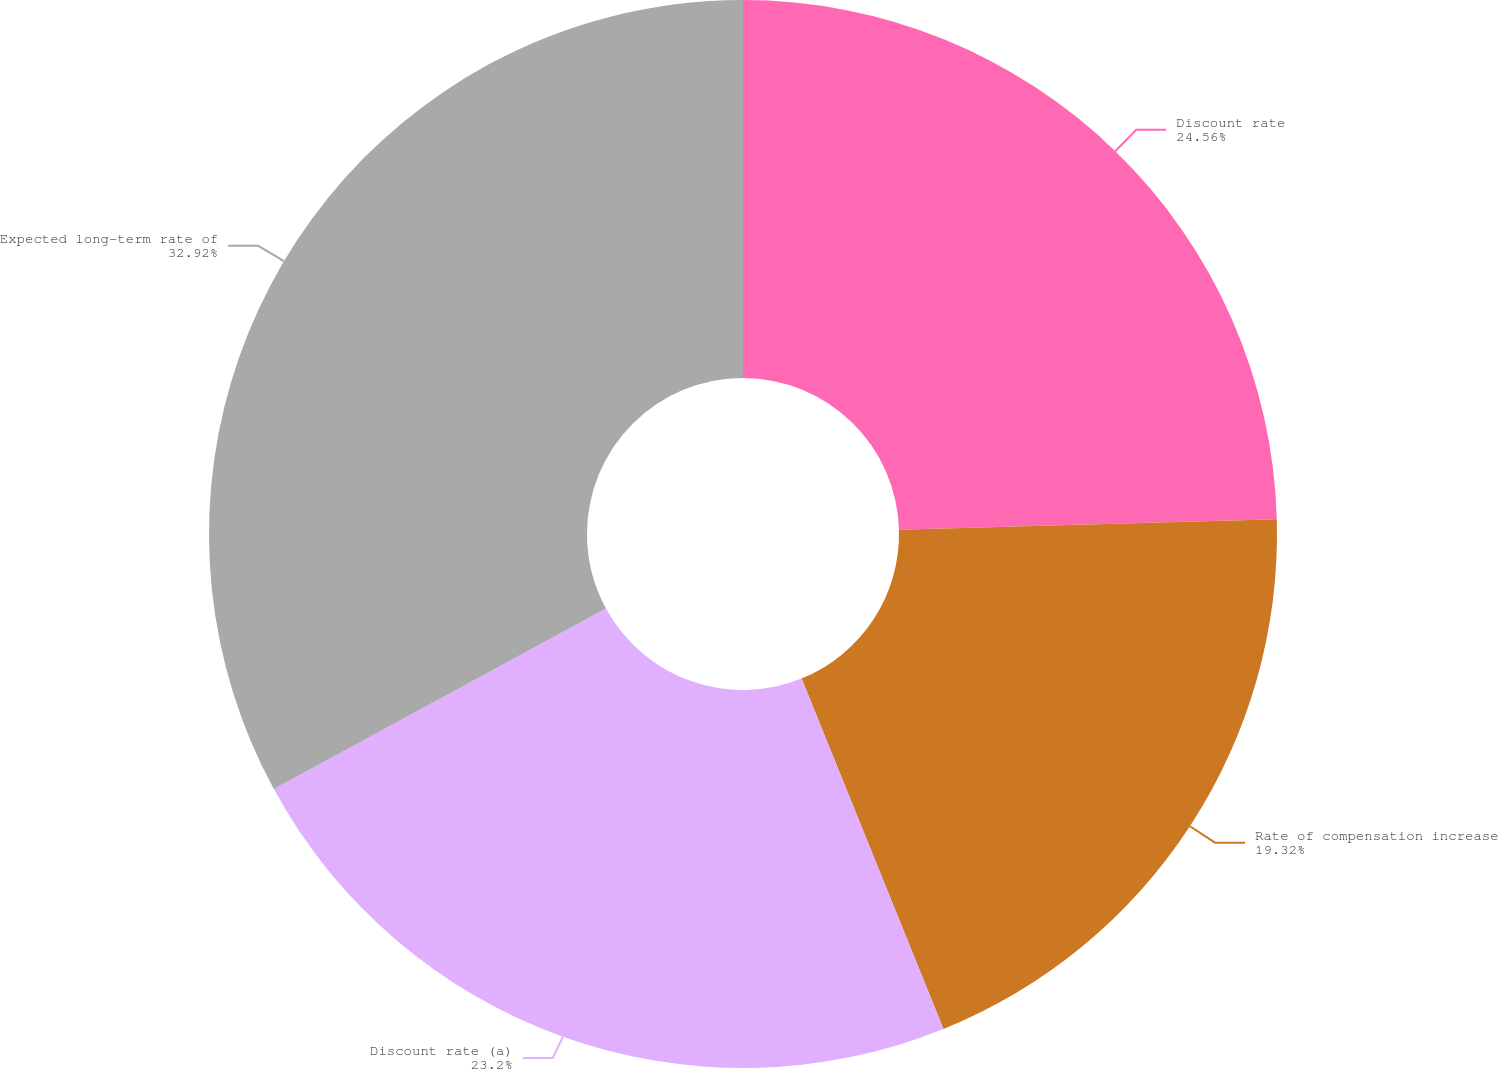Convert chart to OTSL. <chart><loc_0><loc_0><loc_500><loc_500><pie_chart><fcel>Discount rate<fcel>Rate of compensation increase<fcel>Discount rate (a)<fcel>Expected long-term rate of<nl><fcel>24.56%<fcel>19.32%<fcel>23.2%<fcel>32.93%<nl></chart> 